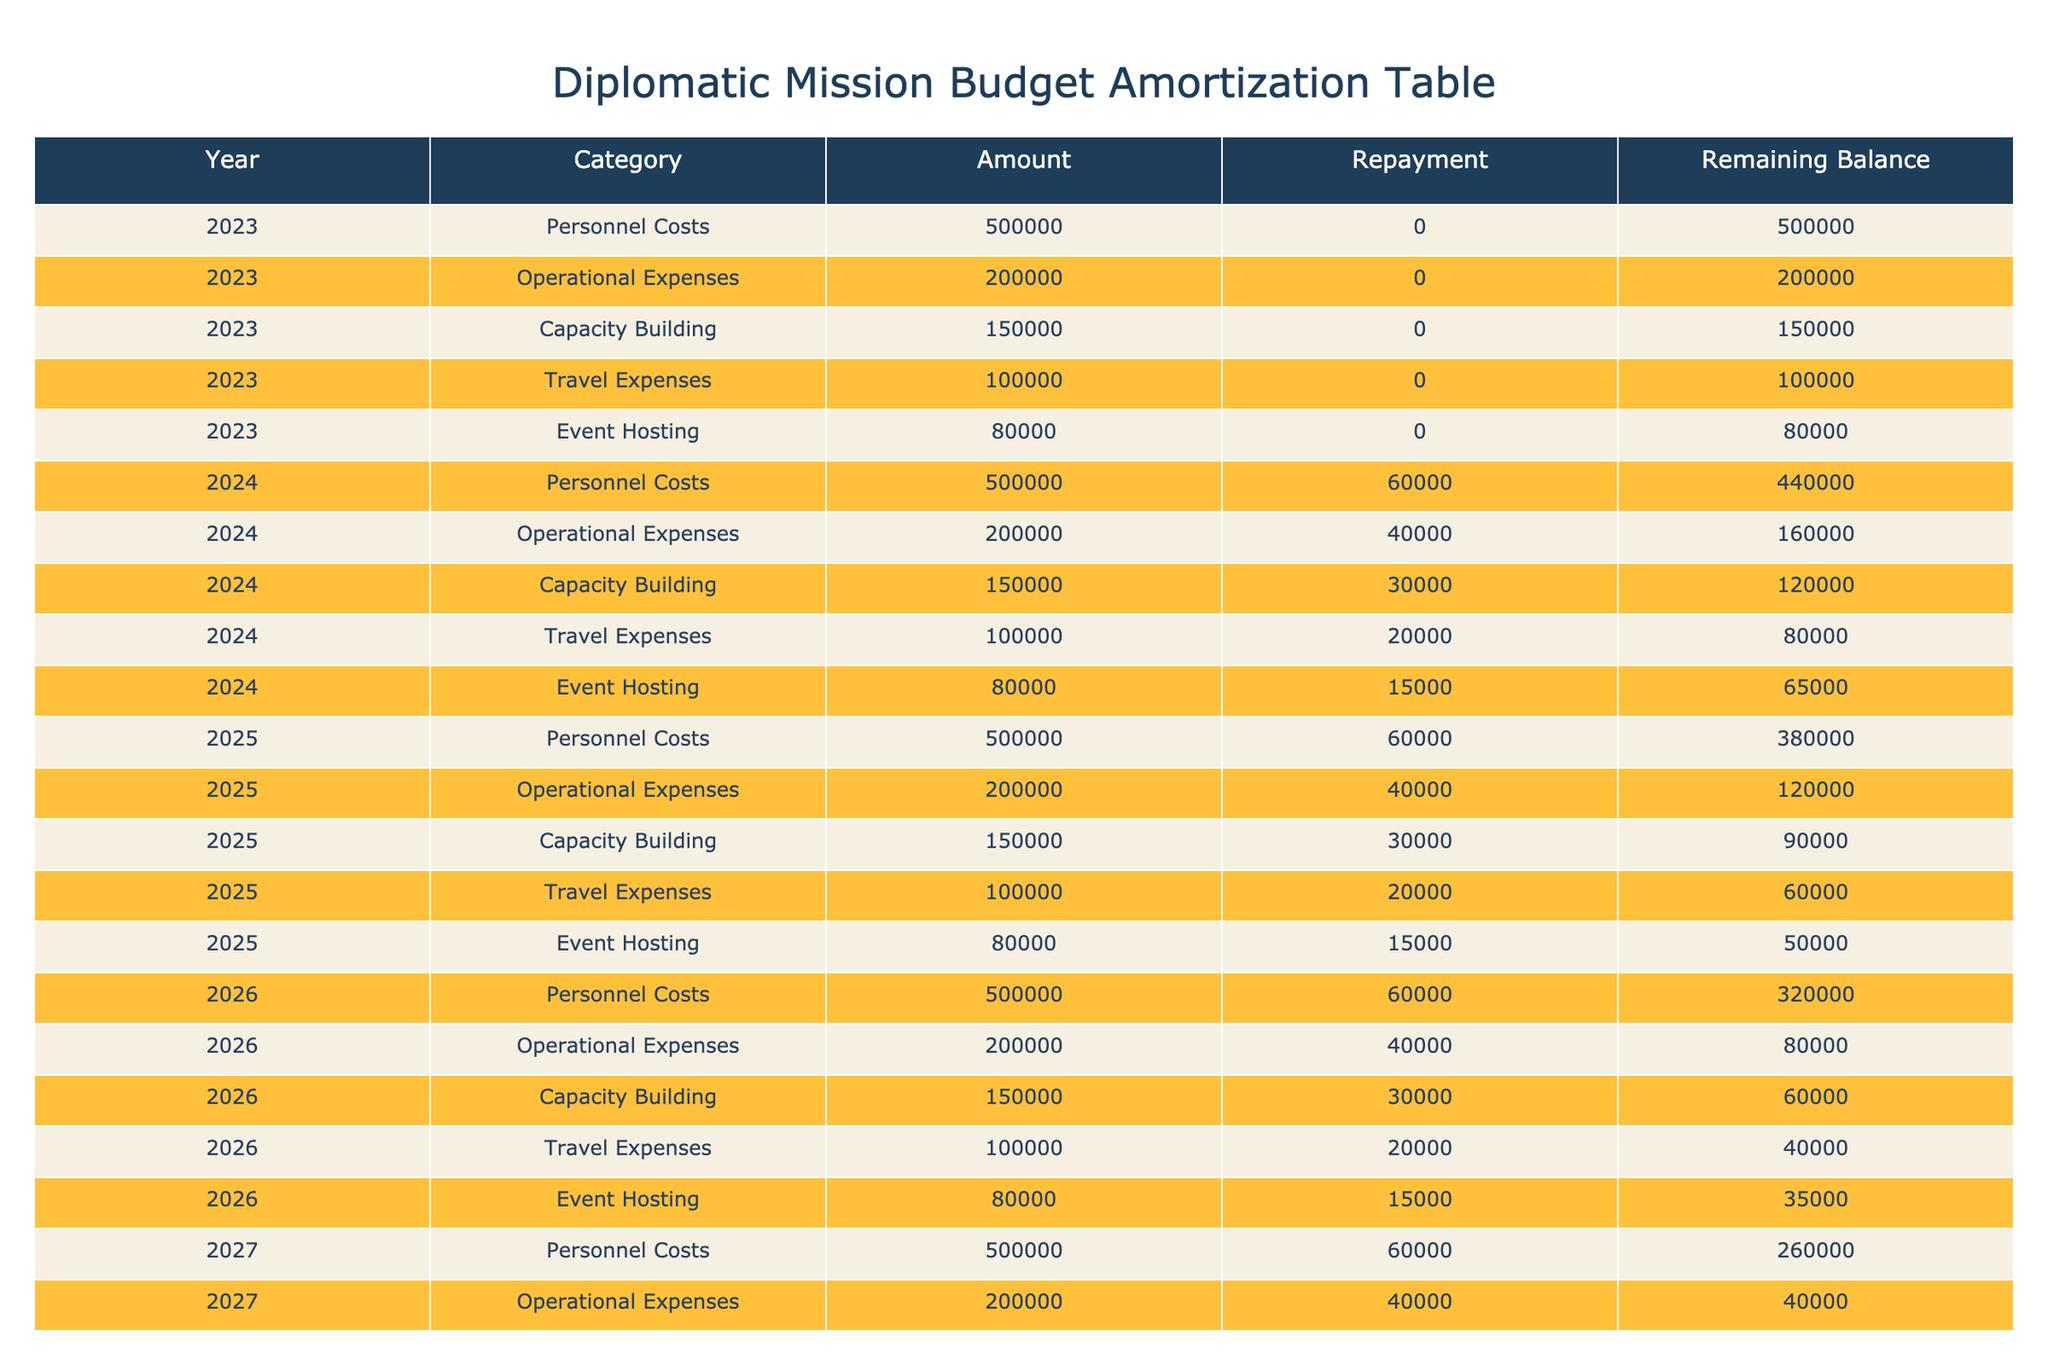What are the total Personnel Costs for the year 2024? In 2024, the Personnel Costs are listed as 500000. Since there is only one entry for this category within this year, the total is the same as the listed amount.
Answer: 500000 What was the total amount spent on Travel Expenses from 2023 to 2025? Summing the Travel Expenses for 2023 (100000), 2024 (100000), and 2025 (100000) gives: 100000 + 100000 + 100000 = 300000.
Answer: 300000 Did the Operational Expenses decrease from 2024 to 2025? A decrease means that the amount in 2025 would be less than in 2024. The Operational Expenses were 200000 in both years, so there was no decrease.
Answer: No What is the remaining balance for Capacity Building at the end of 2026? The remaining balance for Capacity Building in 2026 is directly provided in the table as 60000.
Answer: 60000 How much more was spent on Event Hosting in 2023 compared to 2027? The Event Hosting costs for 2023 are 80000, while for 2027, they are 20000. The difference is calculated as 80000 - 20000 = 60000.
Answer: 60000 What was the total repayment amount made for Operational Expenses by the end of 2026? The repayments for Operational Expenses from 2024 to 2026 are 40000, 40000, and 40000, respectively. Summing these gives: 40000 + 40000 + 40000 = 120000.
Answer: 120000 Is the total budget for Travel Expenses lower than the budget for Event Hosting across all years combined? The total Travel Expenses across the years are 300000 (100000 + 100000 + 100000), and for Event Hosting, it is 225000 (80000 + 65000 + 50000). Since 300000 is greater than 225000, the statement is false.
Answer: No What is the average repayment amount per year for Personnel Costs from 2024 to 2027? The repayment amounts for Personnel Costs from 2024 to 2027 are 60000 for each year. To find the average, add these values: (60000 + 60000 + 60000 + 60000) = 240000, then divide by the number of years (4): 240000 / 4 = 60000.
Answer: 60000 